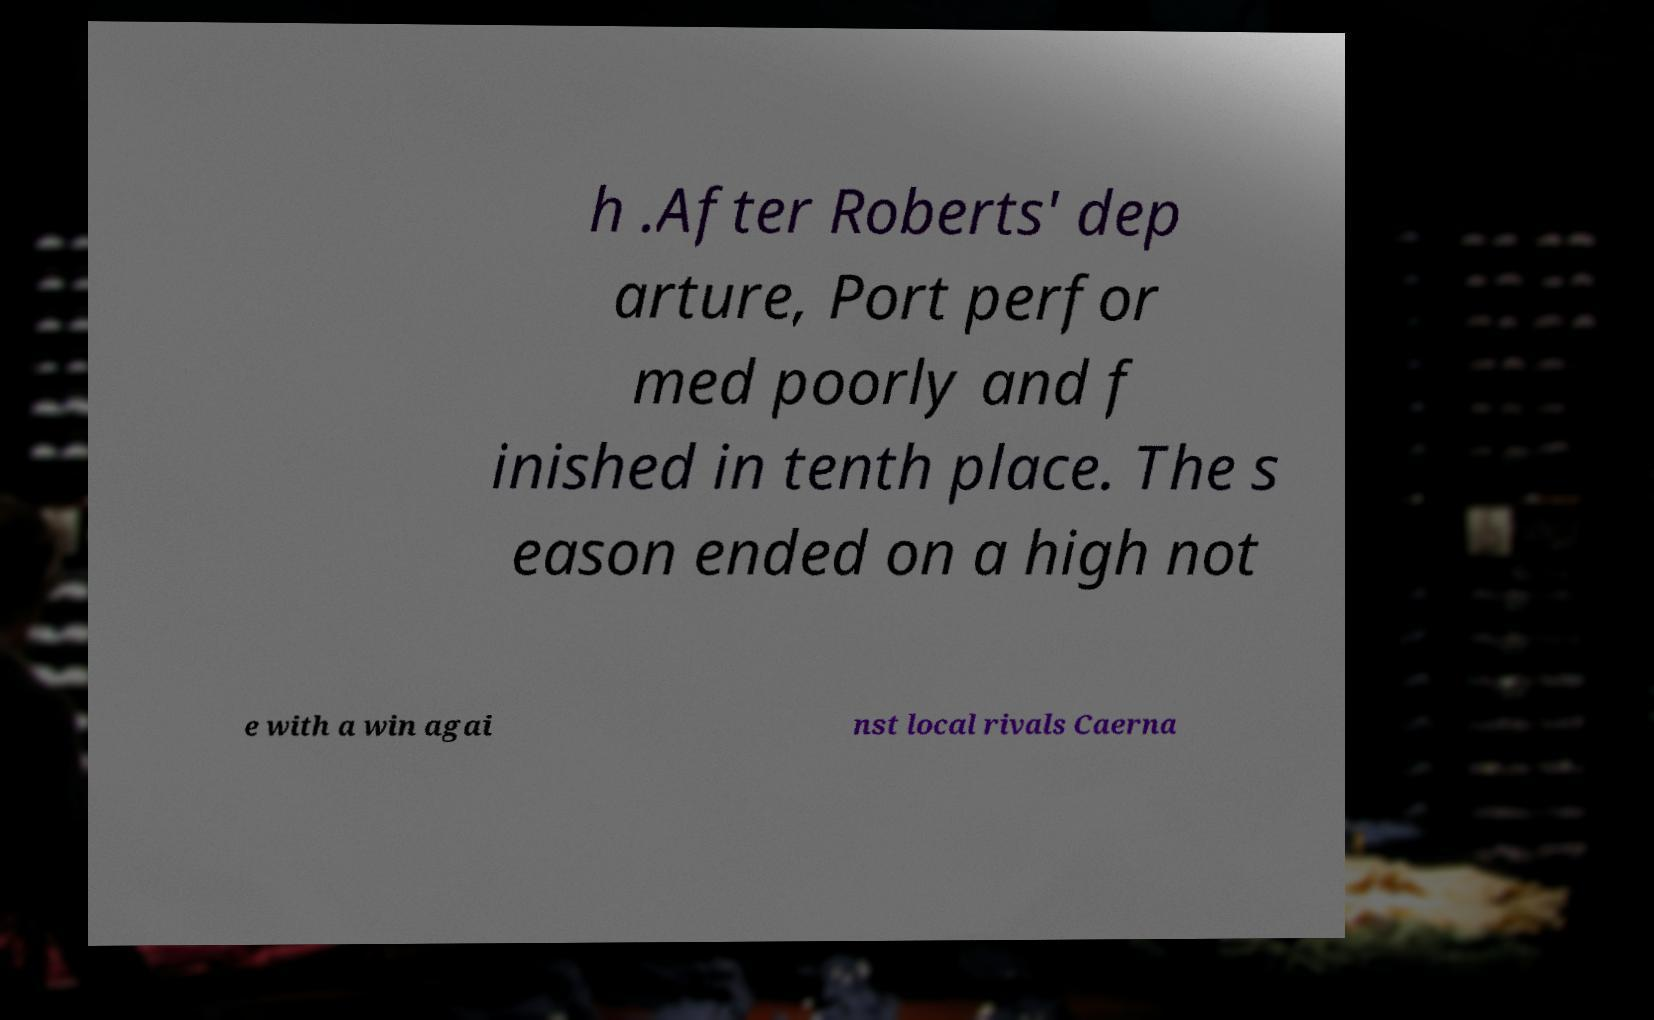There's text embedded in this image that I need extracted. Can you transcribe it verbatim? h .After Roberts' dep arture, Port perfor med poorly and f inished in tenth place. The s eason ended on a high not e with a win agai nst local rivals Caerna 